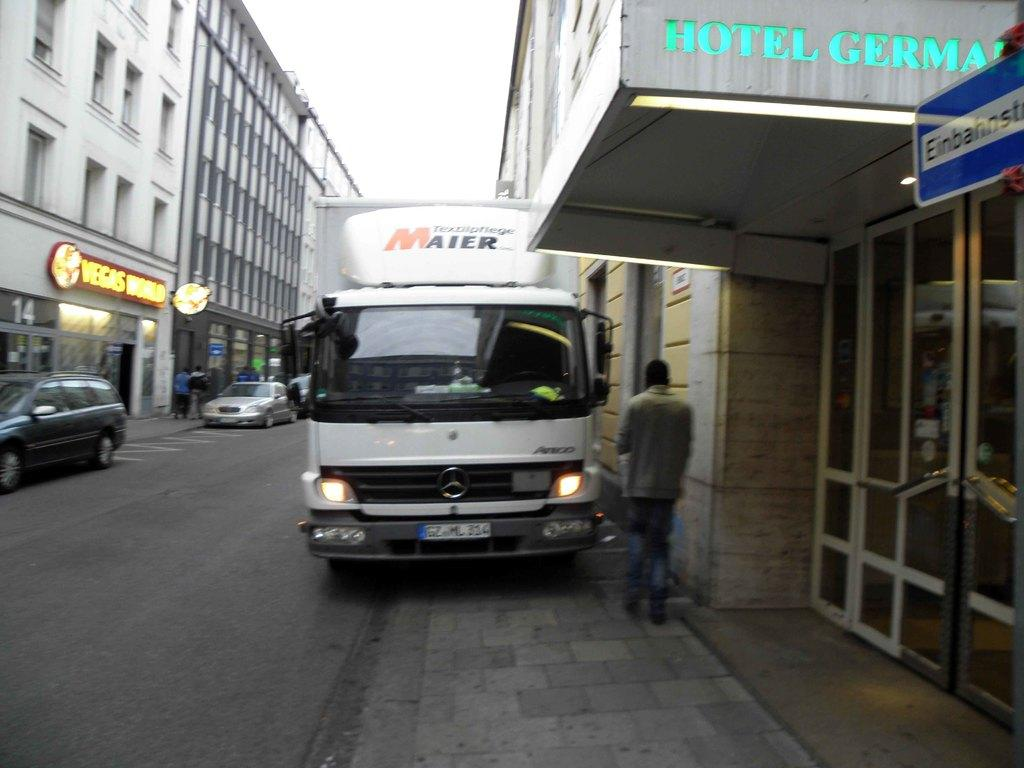What type of structures are present in the image? There are big buildings in the image. What else can be seen on the ground in the image? There are vehicles on the road in the image. Are there any people visible in the image? Yes, there are people walking in the image. What might be used to identify specific locations or businesses in the image? There are name boards in the image. What is visible at the top of the image? The sky is visible at the top of the image. Can you tell me how many mountains are visible in the image? There are no mountains present in the image; it features big buildings, vehicles, people, name boards, and the sky. What is the temperature of the hot air balloon in the image? There is no hot air balloon present in the image. 